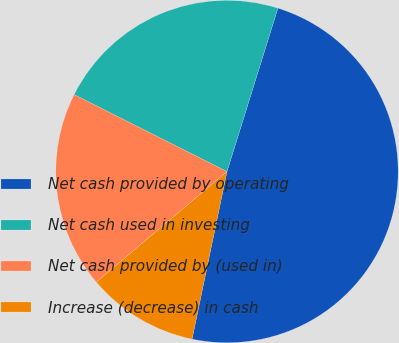Convert chart to OTSL. <chart><loc_0><loc_0><loc_500><loc_500><pie_chart><fcel>Net cash provided by operating<fcel>Net cash used in investing<fcel>Net cash provided by (used in)<fcel>Increase (decrease) in cash<nl><fcel>48.47%<fcel>22.39%<fcel>18.6%<fcel>10.55%<nl></chart> 